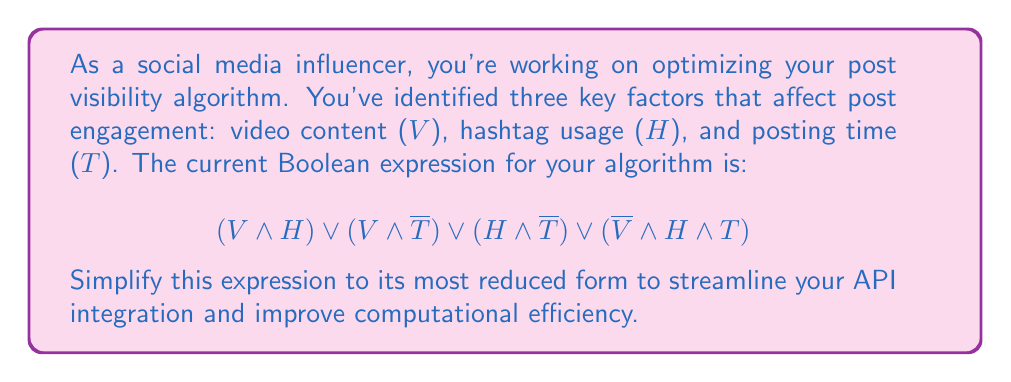Solve this math problem. Let's simplify this Boolean expression step by step using Boolean algebra laws:

1) First, we can apply the distributive law to the first two terms:
   $V \land (H \lor \overline{T}) \lor (H \land \overline{T}) \lor (\overline{V} \land H \land T)$

2) Now, let's focus on the term $(H \land \overline{T})$. We can factor this out:
   $V \land (H \lor \overline{T}) \lor (H \land \overline{T}) \lor (\overline{V} \land H \land T)$
   $= [V \land (H \lor \overline{T})] \lor [(H \land \overline{T}) \lor (\overline{V} \land H \land T)]$

3) In the second bracket, we can factor out $H$:
   $[V \land (H \lor \overline{T})] \lor [H \land (\overline{T} \lor (\overline{V} \land T))]$

4) Inside the parentheses in the second bracket, we can apply the absorption law:
   $\overline{T} \lor (\overline{V} \land T) = \overline{T} \lor \overline{V}$

5) So now our expression is:
   $[V \land (H \lor \overline{T})] \lor [H \land (\overline{T} \lor \overline{V})]$

6) Applying the distributive law to the second bracket:
   $[V \land (H \lor \overline{T})] \lor [(H \land \overline{T}) \lor (H \land \overline{V})]$

7) Now we can use the associative law to rearrange:
   $[V \land (H \lor \overline{T})] \lor (H \land \overline{T}) \lor (H \land \overline{V})$

8) The term $(H \land \overline{T})$ appears in both the first and second parts. We can factor this out:
   $(H \land \overline{T}) \lor [V \land H] \lor (H \land \overline{V})$

9) Rearranging the terms:
   $(H \land \overline{T}) \lor (H \land V) \lor (H \land \overline{V})$

10) We can factor out $H$:
    $H \land (\overline{T} \lor V \lor \overline{V})$

11) $V \lor \overline{V}$ is always true, so this simplifies to:
    $H \land (\overline{T} \lor 1) = H$

Therefore, the simplified expression is just $H$.
Answer: $H$ 